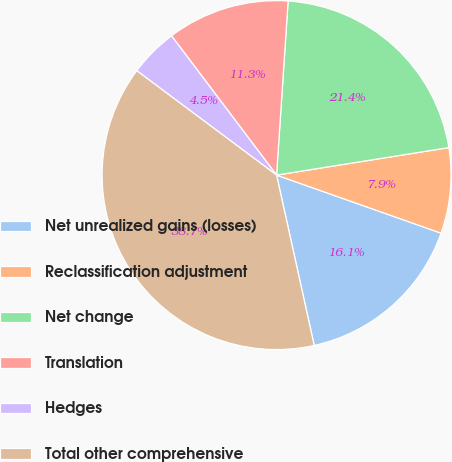<chart> <loc_0><loc_0><loc_500><loc_500><pie_chart><fcel>Net unrealized gains (losses)<fcel>Reclassification adjustment<fcel>Net change<fcel>Translation<fcel>Hedges<fcel>Total other comprehensive<nl><fcel>16.14%<fcel>7.92%<fcel>21.43%<fcel>11.34%<fcel>4.51%<fcel>38.67%<nl></chart> 